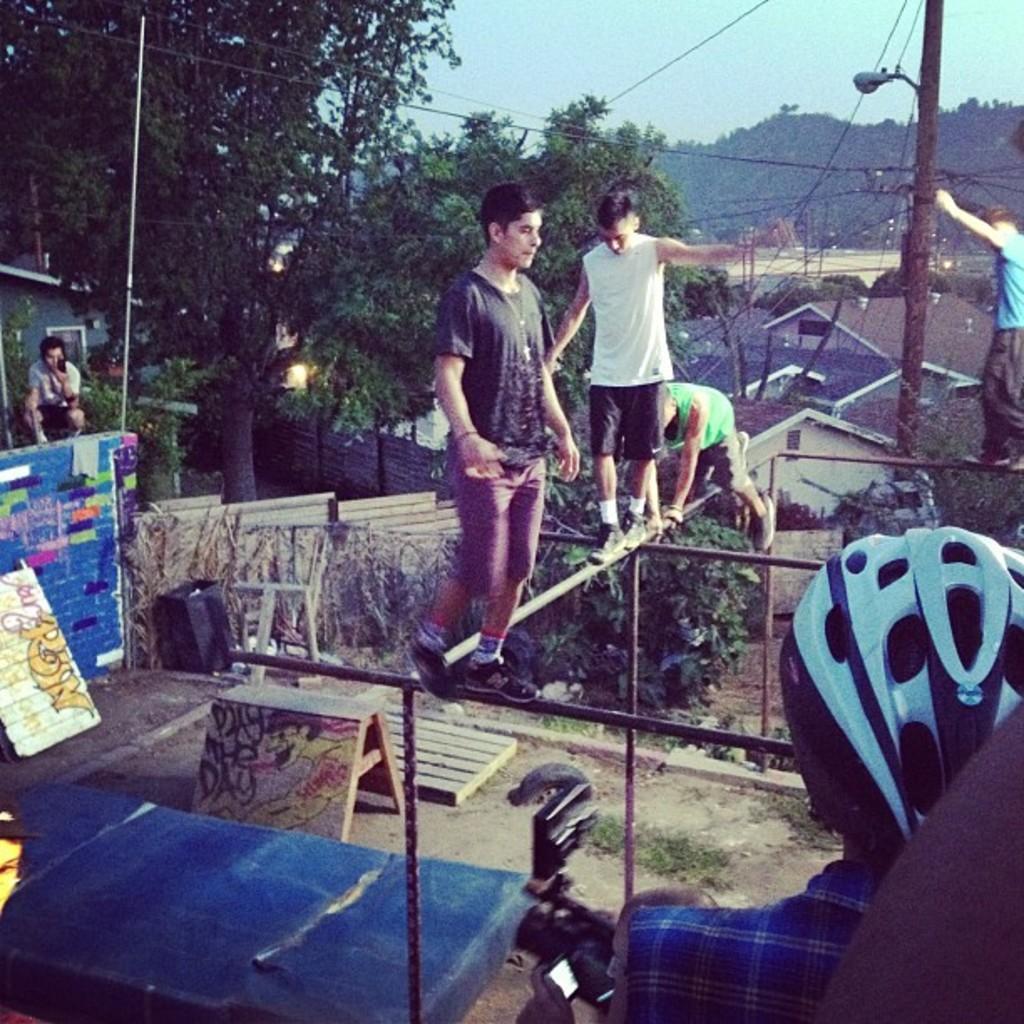Can you describe this image briefly? In the picture I can see four persons standing on rods and there is a person wearing helmet in the right corner and there are few trees and some other objects in the background. 